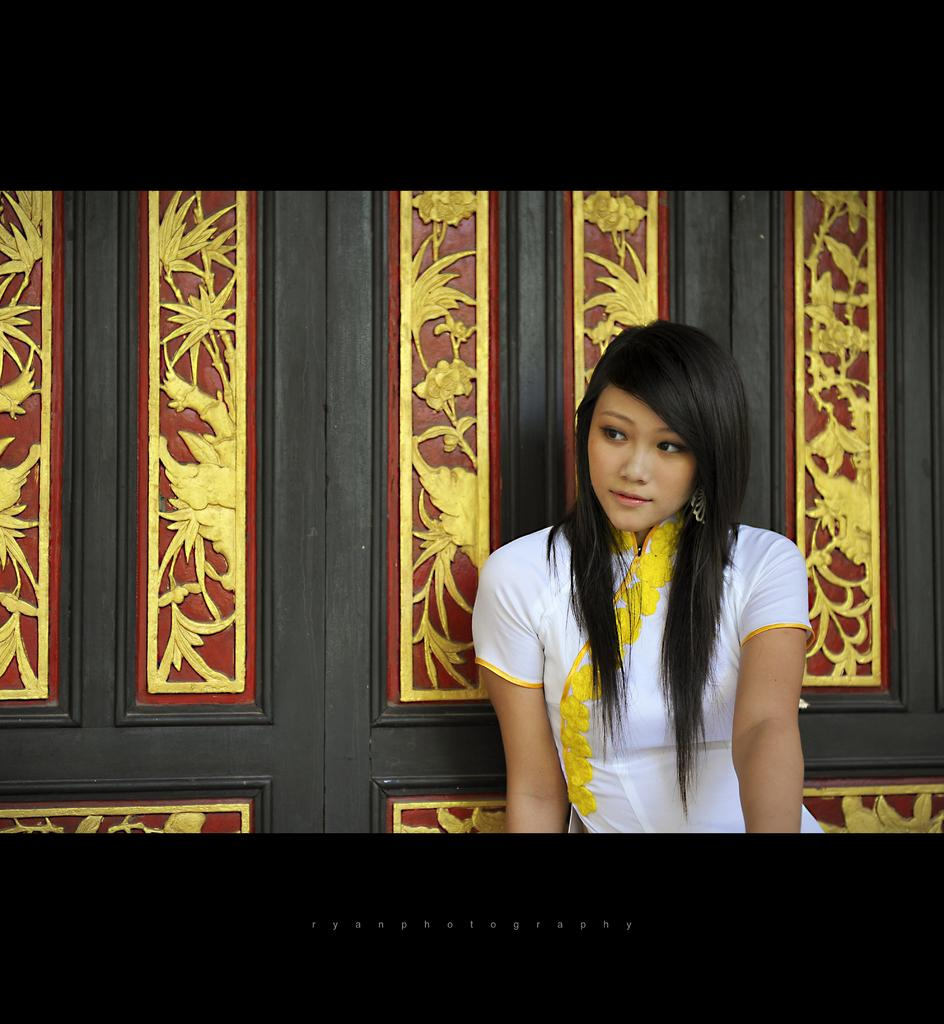Who is present in the image? There is a lady in the image. What can be seen in the background of the image? There is a wooden wall with designs in the background. How is the wooden wall framed? The wooden wall has a black border at the top and bottom. What is located at the bottom of the image? There is text at the bottom of the image. What type of brass instrument is being played by the lady in the image? A: There is no brass instrument or any indication of music in the image; the lady is not playing any instrument. 